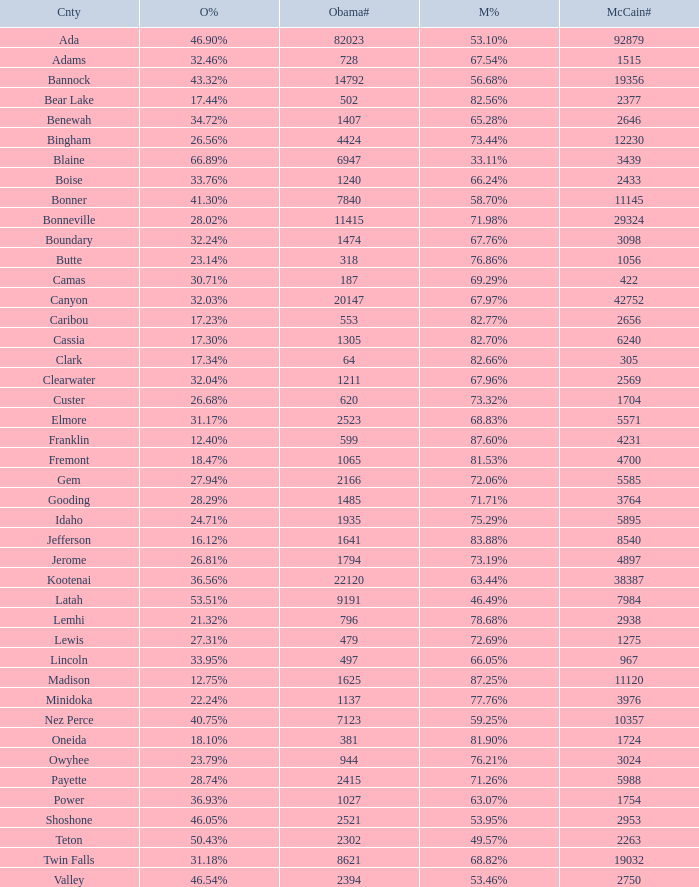What is the maximum McCain population turnout number? 92879.0. 